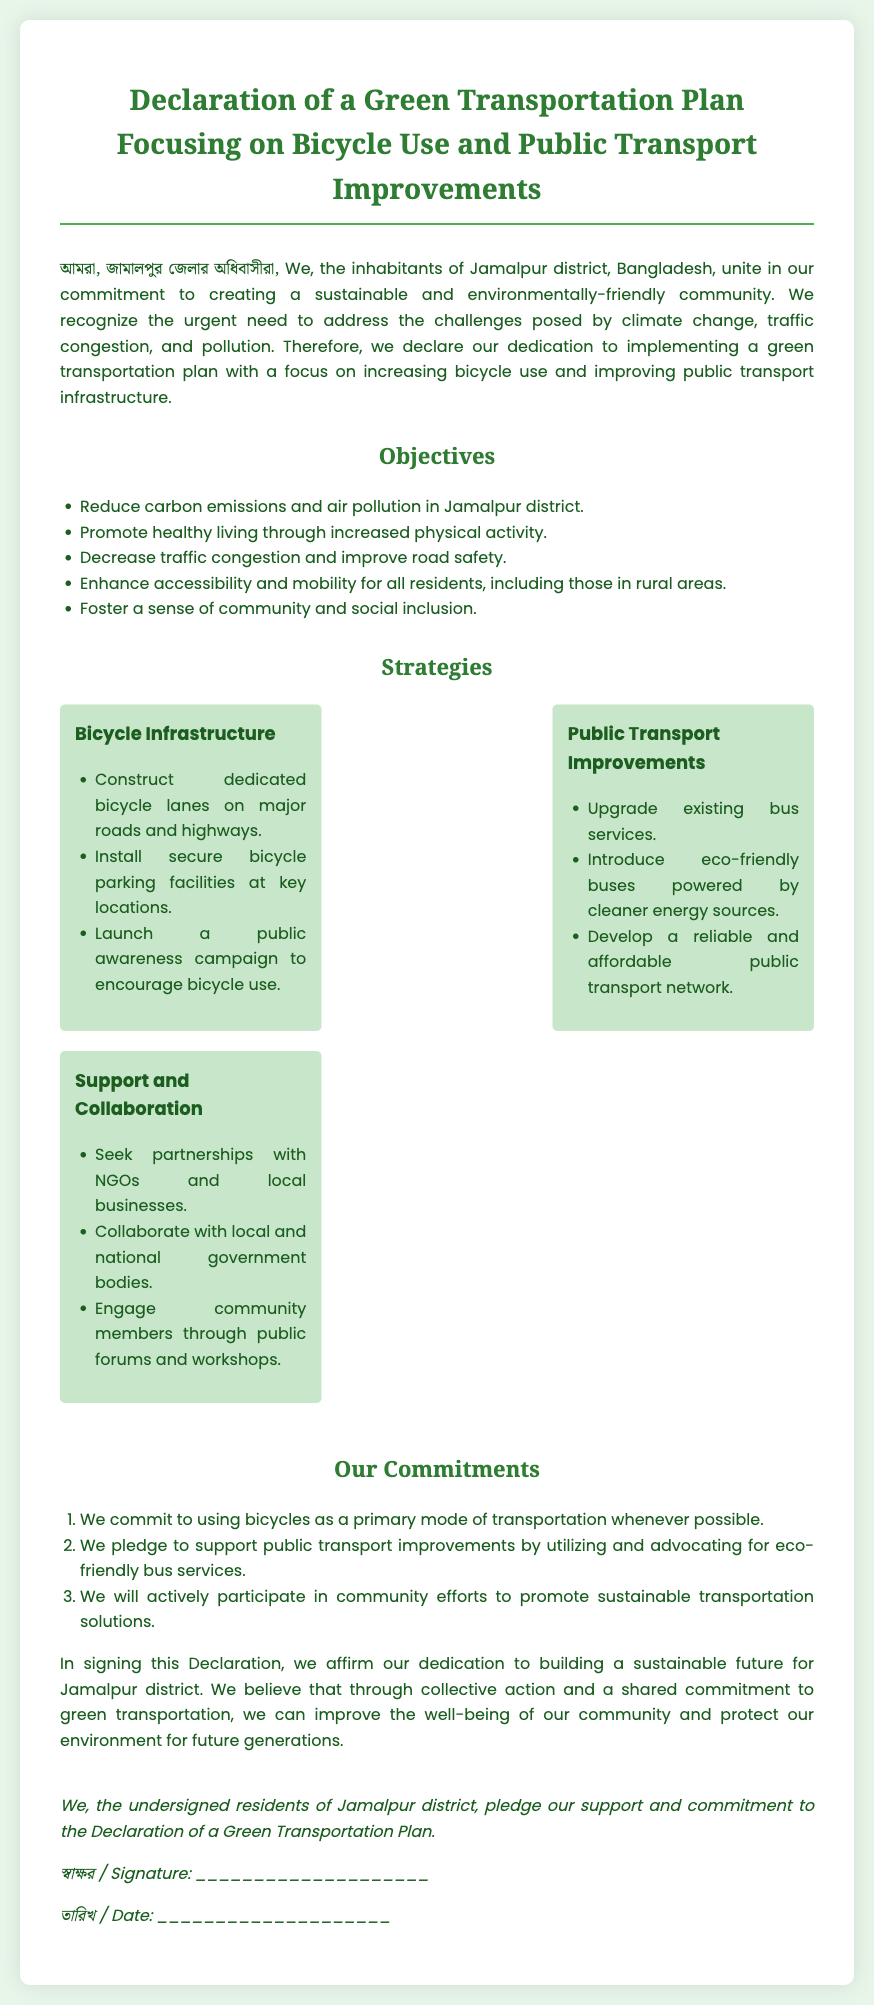What is the main focus of the Green Transportation Plan? The document highlights the main focus on increasing bicycle use and improving public transport infrastructure.
Answer: Bicycle use and public transport improvements What is one objective of the plan? The document lists objectives that include reducing carbon emissions and air pollution in Jamalpur district.
Answer: Reduce carbon emissions How many strategies are outlined in the document? The document presents three strategies for implementing the plan.
Answer: Three What type of vehicles are mentioned for public transport improvements? The document specifies that eco-friendly buses powered by cleaner energy sources will be introduced.
Answer: Eco-friendly buses What commitment do residents make regarding bicycles? The residents commit to using bicycles as a primary mode of transportation whenever possible.
Answer: Using bicycles Who are the intended partners for support and collaboration? The document mentions seeking partnerships with NGOs and local businesses.
Answer: NGOs and local businesses What is the date section labeled as in Bengali? The document includes the term "তারিখ" for the date section in Bengali.
Answer: তারিখ What is the significance of the declaration in terms of community? The document states that it aims to improve the well-being of the community and protect the environment for future generations.
Answer: Improve well-being and protect the environment 